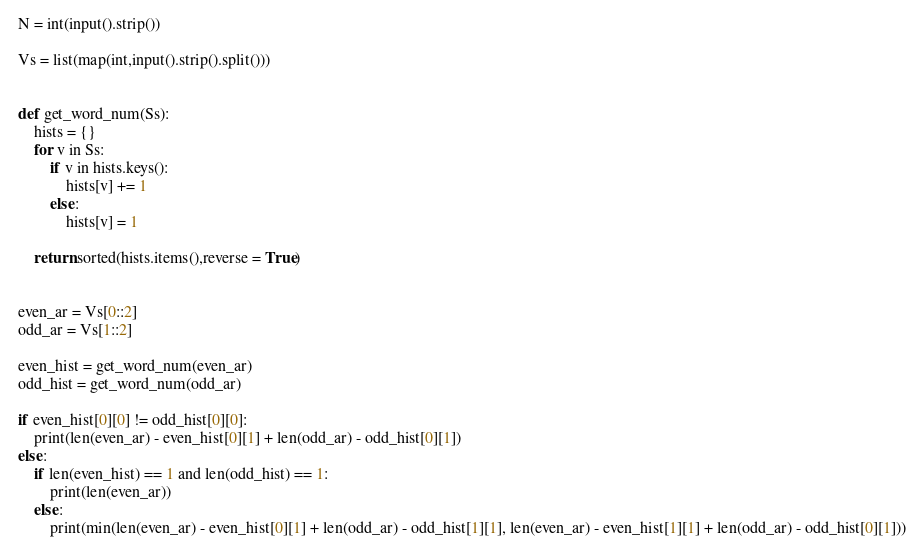Convert code to text. <code><loc_0><loc_0><loc_500><loc_500><_Python_>N = int(input().strip())

Vs = list(map(int,input().strip().split()))


def get_word_num(Ss):
    hists = {}
    for v in Ss:
        if v in hists.keys():
            hists[v] += 1
        else:
            hists[v] = 1

    return sorted(hists.items(),reverse = True)


even_ar = Vs[0::2]
odd_ar = Vs[1::2]

even_hist = get_word_num(even_ar)
odd_hist = get_word_num(odd_ar)

if even_hist[0][0] != odd_hist[0][0]:
    print(len(even_ar) - even_hist[0][1] + len(odd_ar) - odd_hist[0][1])
else:
    if len(even_hist) == 1 and len(odd_hist) == 1:
        print(len(even_ar))
    else:
        print(min(len(even_ar) - even_hist[0][1] + len(odd_ar) - odd_hist[1][1], len(even_ar) - even_hist[1][1] + len(odd_ar) - odd_hist[0][1]))
</code> 